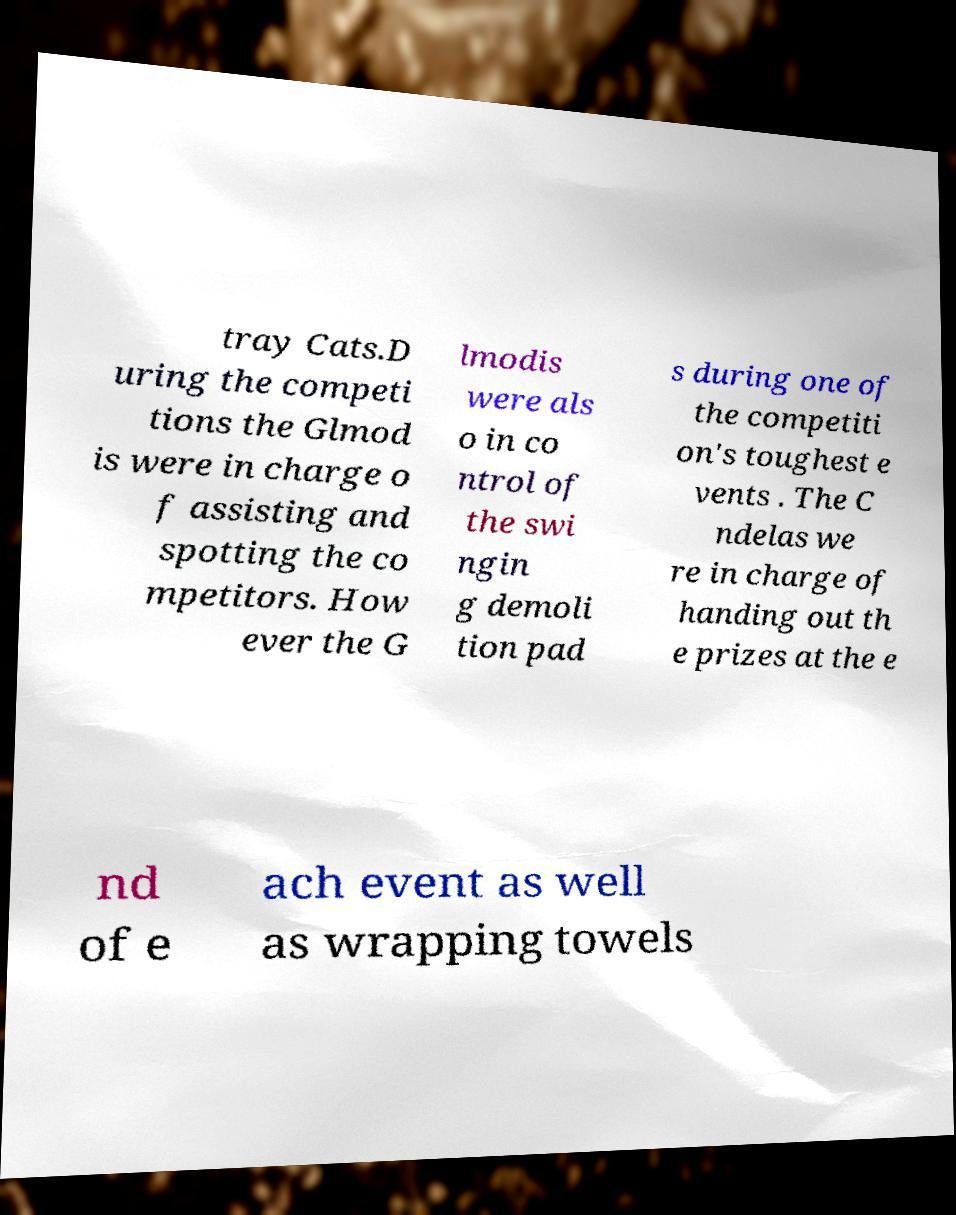What messages or text are displayed in this image? I need them in a readable, typed format. tray Cats.D uring the competi tions the Glmod is were in charge o f assisting and spotting the co mpetitors. How ever the G lmodis were als o in co ntrol of the swi ngin g demoli tion pad s during one of the competiti on's toughest e vents . The C ndelas we re in charge of handing out th e prizes at the e nd of e ach event as well as wrapping towels 